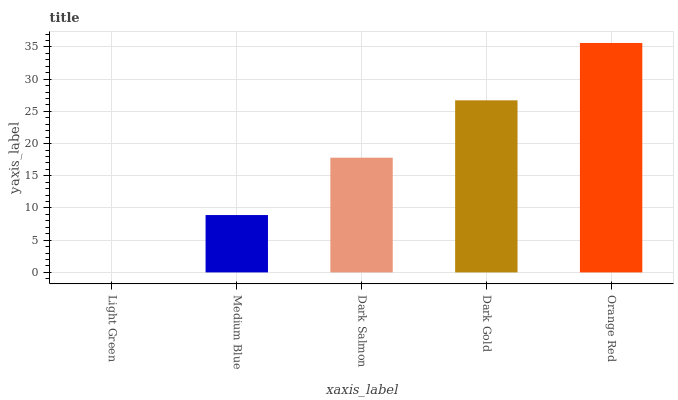Is Light Green the minimum?
Answer yes or no. Yes. Is Orange Red the maximum?
Answer yes or no. Yes. Is Medium Blue the minimum?
Answer yes or no. No. Is Medium Blue the maximum?
Answer yes or no. No. Is Medium Blue greater than Light Green?
Answer yes or no. Yes. Is Light Green less than Medium Blue?
Answer yes or no. Yes. Is Light Green greater than Medium Blue?
Answer yes or no. No. Is Medium Blue less than Light Green?
Answer yes or no. No. Is Dark Salmon the high median?
Answer yes or no. Yes. Is Dark Salmon the low median?
Answer yes or no. Yes. Is Orange Red the high median?
Answer yes or no. No. Is Dark Gold the low median?
Answer yes or no. No. 